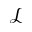Convert formula to latex. <formula><loc_0><loc_0><loc_500><loc_500>\mathcal { L }</formula> 